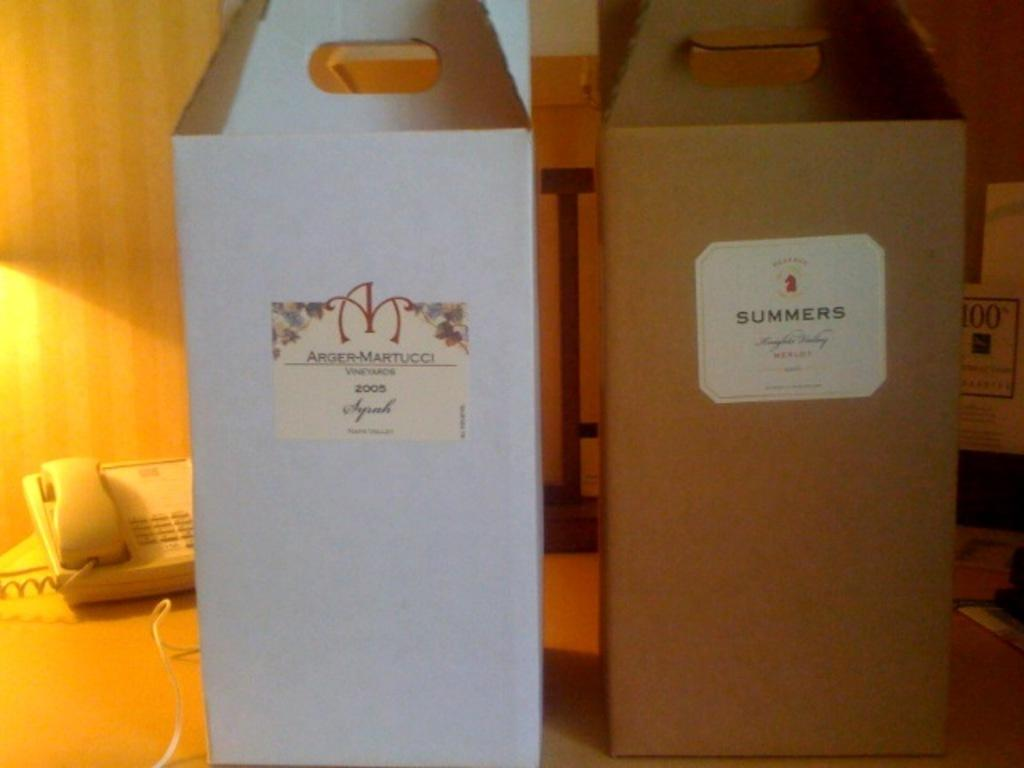<image>
Offer a succinct explanation of the picture presented. two boxes holding a syrah and merlot wine 